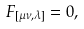Convert formula to latex. <formula><loc_0><loc_0><loc_500><loc_500>F _ { [ \mu \nu , \lambda ] } = 0 ,</formula> 